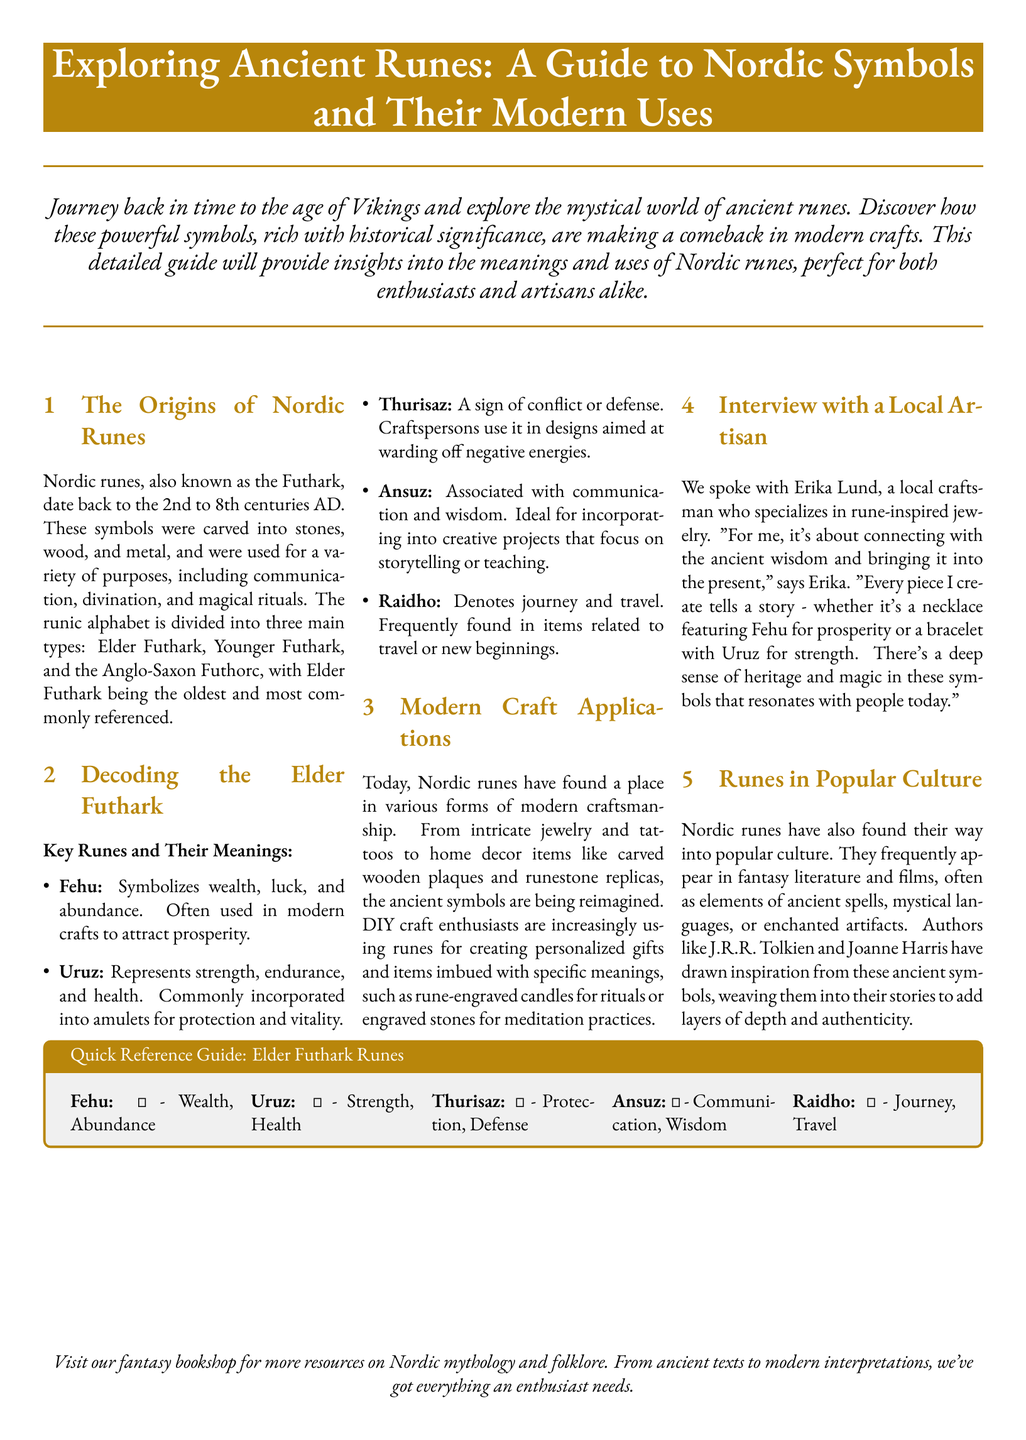What are Nordic runes also known as? Nordic runes are also referred to as the Futhark, a name derived from the first six letters of the runic alphabet.
Answer: Futhark What is the time period during which Nordic runes date back to? The document mentions that Nordic runes date back to the 2nd to 8th centuries AD.
Answer: 2nd to 8th centuries AD Which rune symbolizes wealth and abundance? The rune Fehu is specifically noted for symbolizing wealth, luck, and abundance, often used in crafts to attract prosperity.
Answer: Fehu Who did the interview in the document? The interview was conducted with Erika Lund, a local craftsman specializing in rune-inspired jewelry.
Answer: Erika Lund What modern crafts are Nordic runes incorporated into? Nordic runes have found a place in various forms of modern craftsmanship including jewelry, tattoos, and home decor items.
Answer: Jewelry, tattoos, home decor How many main types of runic alphabet are there? The document mentions three main types of runic alphabet: Elder Futhark, Younger Futhark, and Anglo-Saxon Futhorc.
Answer: Three Which rune represents strength and health? The rune Uruz is associated with strength, endurance, and health, commonly used in amulets for protection.
Answer: Uruz What cultural aspect do Nordic runes often influence? Nordic runes frequently appear in fantasy literature and films, influencing elements such as ancient spells and mystical languages.
Answer: Popular culture What title is given to the quick reference guide section in the document? The section is titled "Quick Reference Guide: Elder Futhark Runes," summarizing the symbols and their meanings.
Answer: Quick Reference Guide: Elder Futhark Runes 